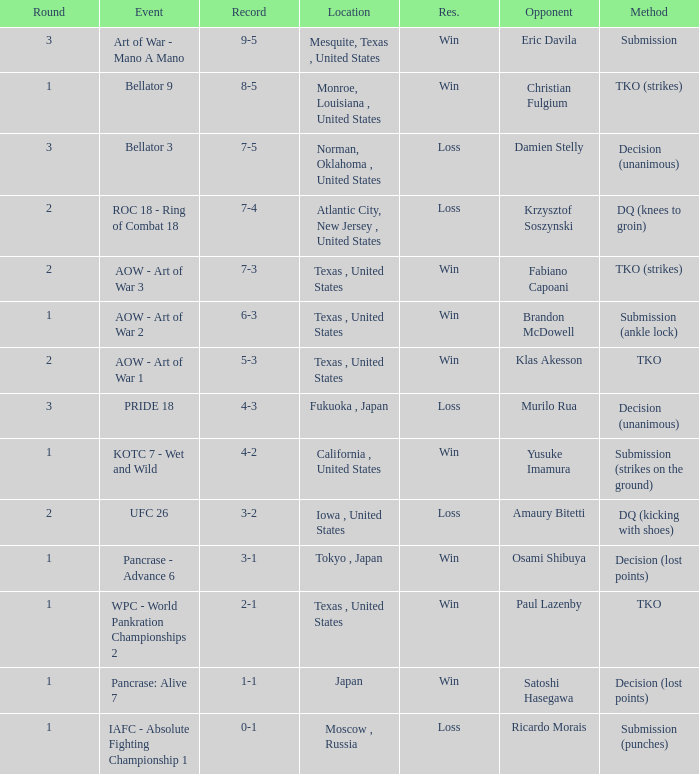What is the average round against opponent Klas Akesson? 2.0. 